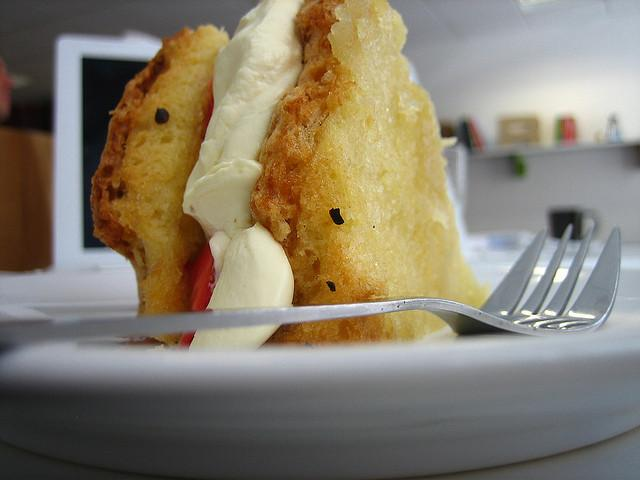What type of fork is included with the meal? metal 